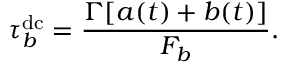<formula> <loc_0><loc_0><loc_500><loc_500>\tau _ { b } ^ { d c } = \frac { \Gamma [ a ( t ) + b ( t ) ] } { F _ { b } } .</formula> 